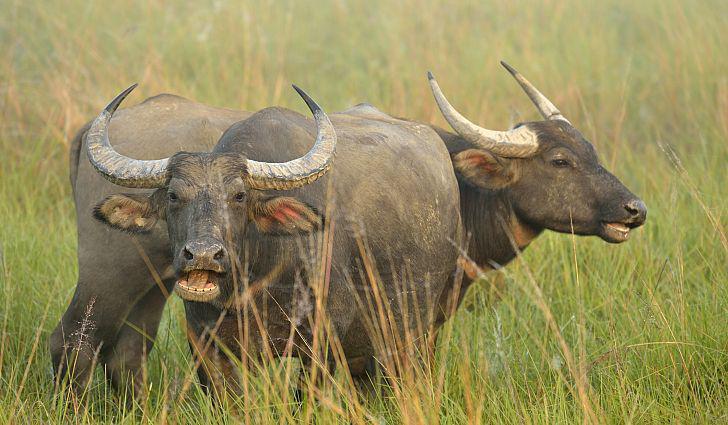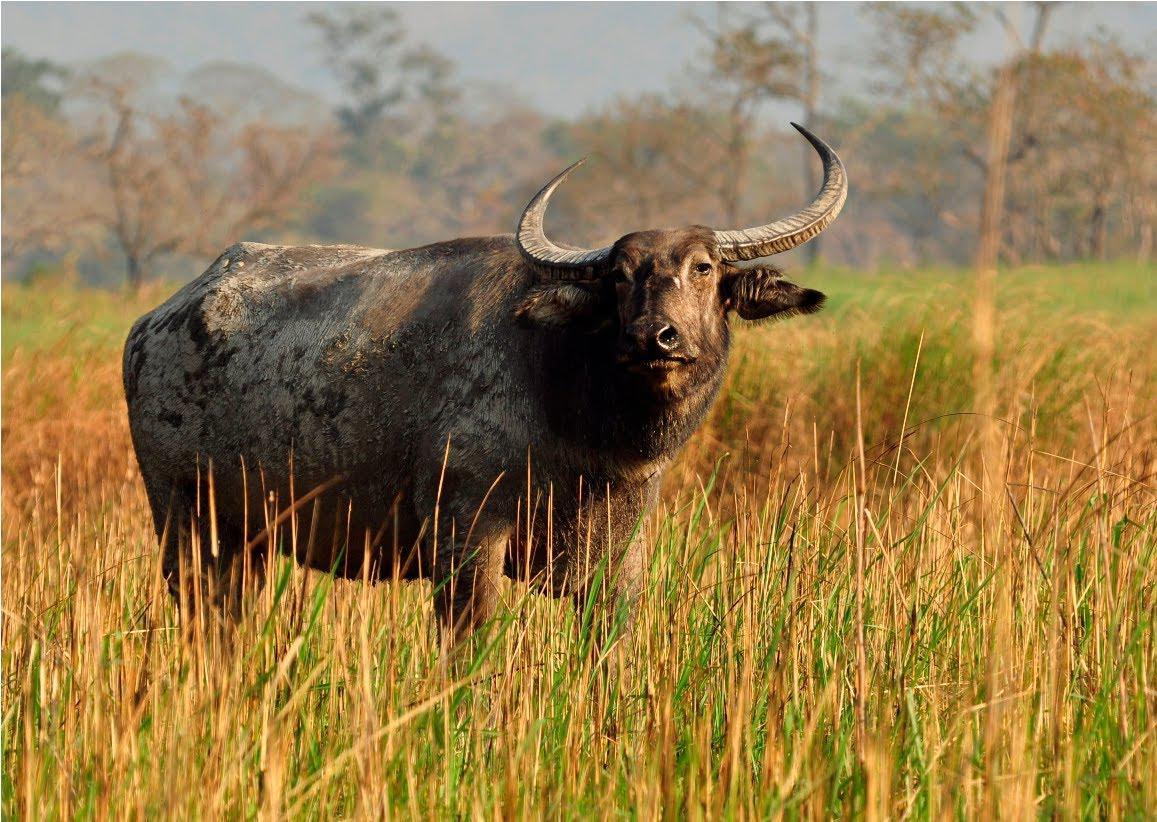The first image is the image on the left, the second image is the image on the right. Assess this claim about the two images: "One of the images contains at least three water buffalo.". Correct or not? Answer yes or no. No. The first image is the image on the left, the second image is the image on the right. Examine the images to the left and right. Is the description "There is exactly one animal in the image on the right." accurate? Answer yes or no. Yes. 